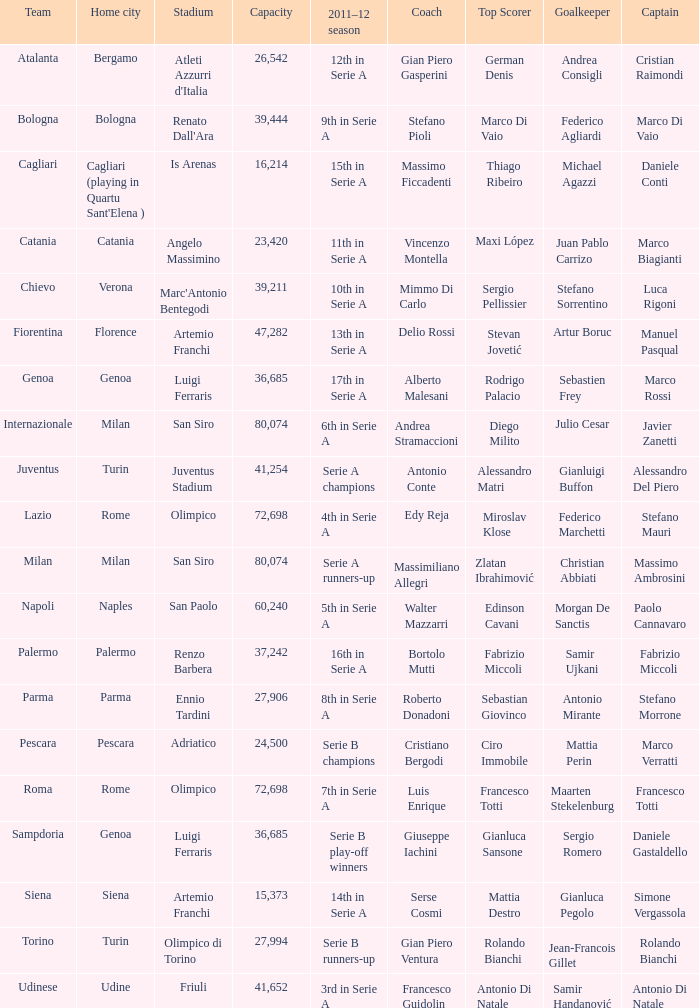What is the home city for angelo massimino stadium? Catania. 